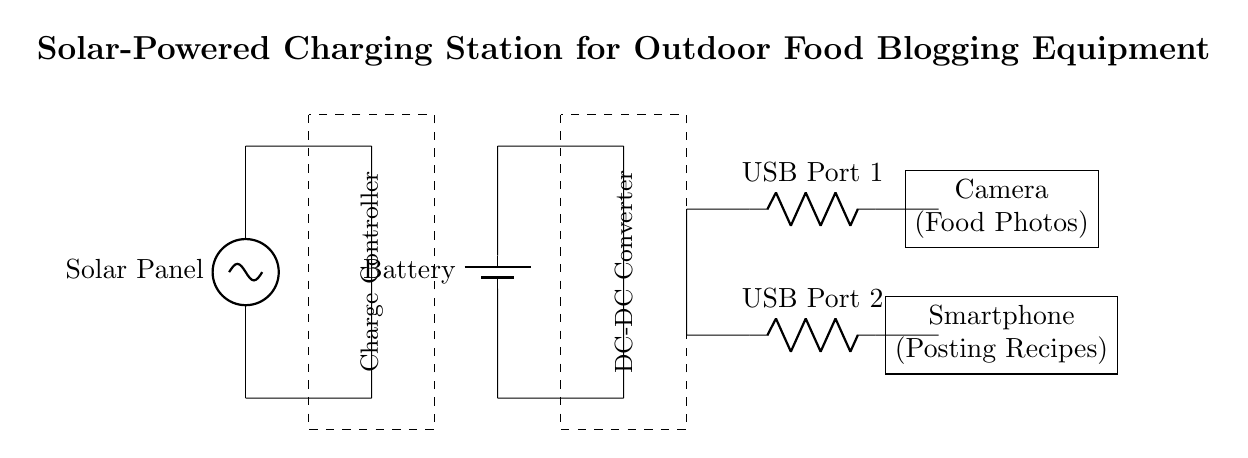What is the main energy source for this circuit? The main energy source is the solar panel, which converts sunlight into electrical energy. This is evident since the solar panel is the first element in the circuit diagram and is labeled accordingly.
Answer: Solar panel What type of controller is used in this circuit? The circuit uses a charge controller, which is indicated by the labeled dashed rectangle in the diagram. The charge controller is essential to regulate the charging of the battery and prevent overcharging.
Answer: Charge controller How many USB ports are available for charging? There are two USB ports present in the circuit, as shown by the two resistors labeled USB Port 1 and USB Port 2 in the diagram.
Answer: Two What does the DC-DC converter do? The DC-DC converter adjusts the output voltage from the battery to a suitable level for charging the connected devices. It is crucial in ensuring that voltage levels are appropriate for the USB charging ports.
Answer: Adjusts voltage What is the purpose of the battery in this circuit? The battery stores energy produced by the solar panel and provides a consistent power supply to the USB ports when needed. This is an essential function indicated in the circuit where the battery is shown connected between the solar panel and the DC-DC converter.
Answer: Energy storage Which devices can be powered by this circuit? The circuit powers a camera and a smartphone, as represented in the diagram where these devices are placed adjacent to the USB ports, indicating that they will be charged using the energy generated.
Answer: Camera and smartphone 